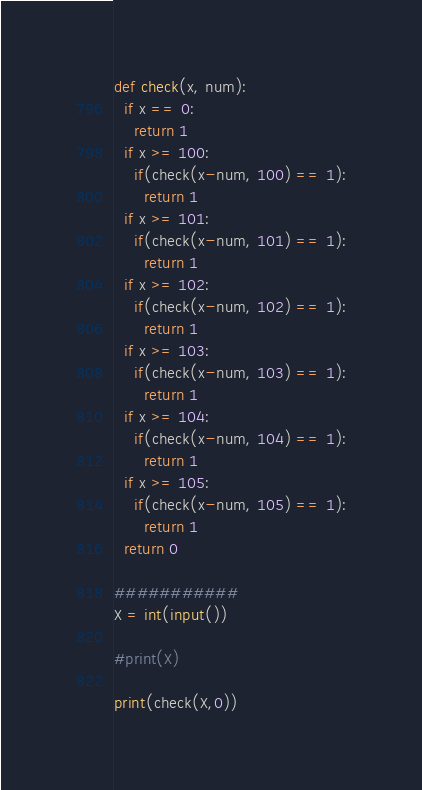<code> <loc_0><loc_0><loc_500><loc_500><_Python_>def check(x, num):
  if x == 0:
    return 1
  if x >= 100:
    if(check(x-num, 100) == 1):
      return 1
  if x >= 101:
    if(check(x-num, 101) == 1):
      return 1
  if x >= 102:
    if(check(x-num, 102) == 1):
      return 1
  if x >= 103:
    if(check(x-num, 103) == 1):
      return 1
  if x >= 104:
    if(check(x-num, 104) == 1):
      return 1
  if x >= 105:
    if(check(x-num, 105) == 1):
      return 1
  return 0
  
###########
X = int(input())

#print(X)

print(check(X,0))
</code> 